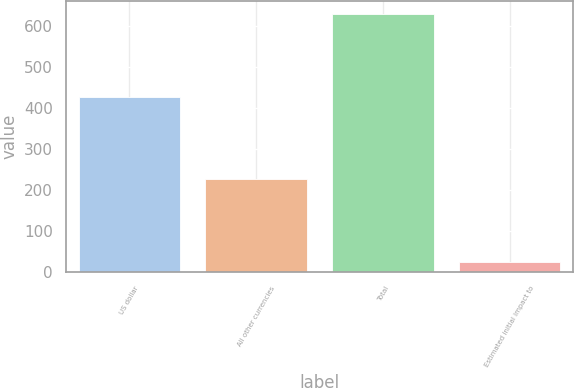<chart> <loc_0><loc_0><loc_500><loc_500><bar_chart><fcel>US dollar<fcel>All other currencies<fcel>Total<fcel>Estimated initial impact to<nl><fcel>427.6<fcel>226.3<fcel>628.9<fcel>25<nl></chart> 